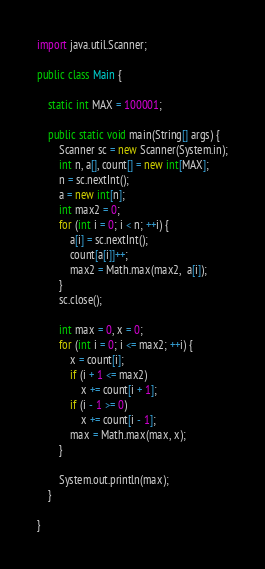<code> <loc_0><loc_0><loc_500><loc_500><_Java_>import java.util.Scanner;

public class Main {

	static int MAX = 100001;

	public static void main(String[] args) {
		Scanner sc = new Scanner(System.in);
		int n, a[], count[] = new int[MAX];
		n = sc.nextInt();
		a = new int[n];
		int max2 = 0;
		for (int i = 0; i < n; ++i) {
			a[i] = sc.nextInt();
			count[a[i]]++;
			max2 = Math.max(max2,  a[i]);
		}
		sc.close();

		int max = 0, x = 0;
		for (int i = 0; i <= max2; ++i) {
			x = count[i];
			if (i + 1 <= max2)
				x += count[i + 1];
			if (i - 1 >= 0)
				x += count[i - 1];
			max = Math.max(max, x);
		}

		System.out.println(max);
	}

}
</code> 